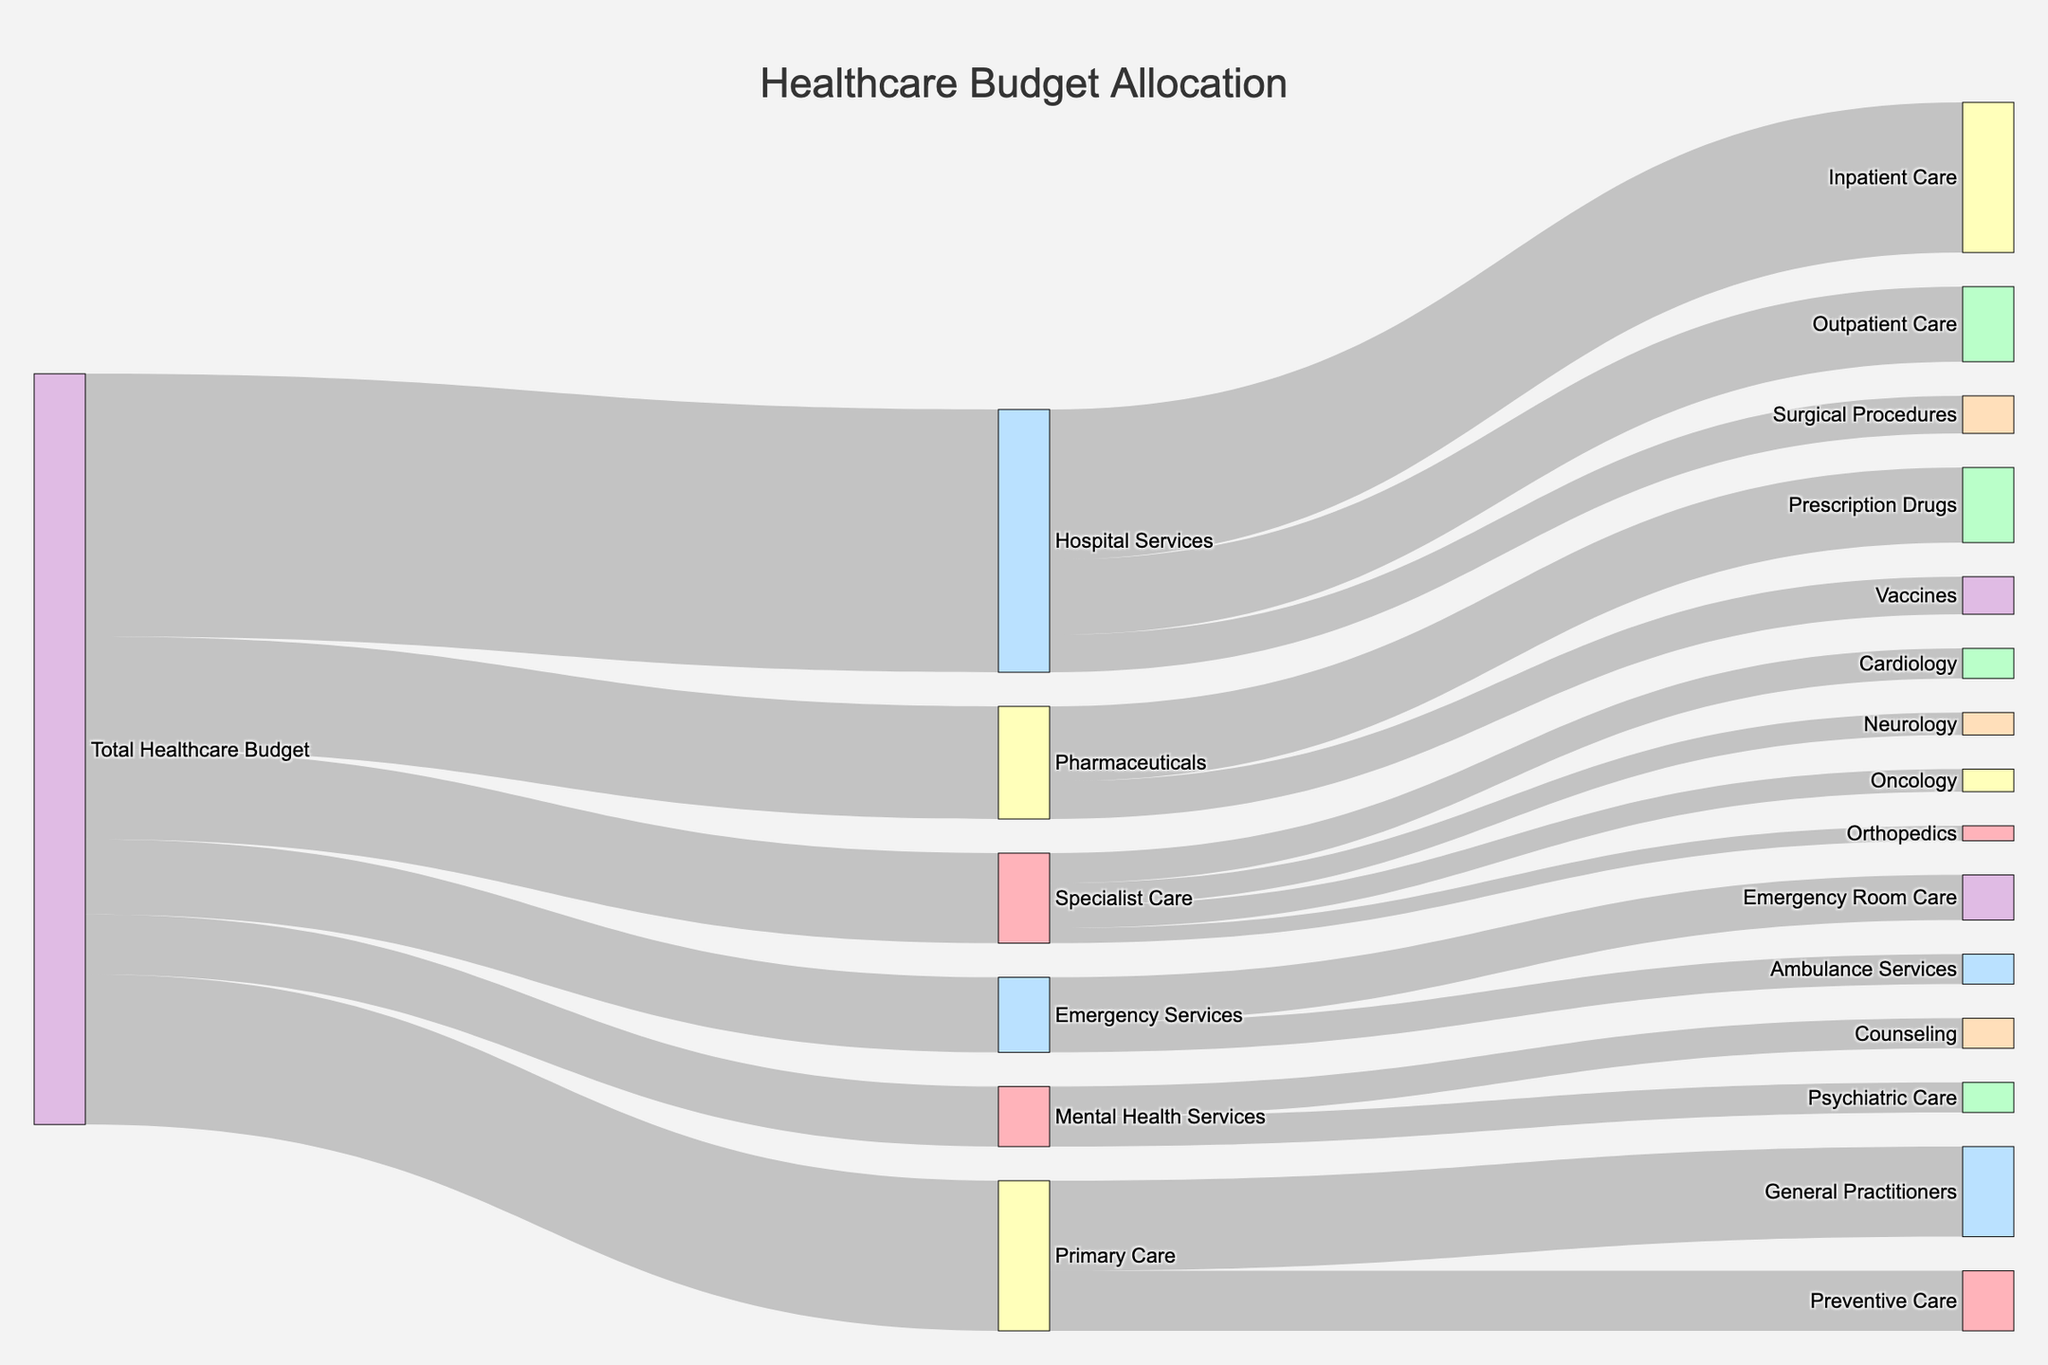What is the title of the figure? The title of the figure is located at the top and is styled in a larger font size, clearly indicating the main subject of the diagram. The title reads 'Healthcare Budget Allocation'.
Answer: Healthcare Budget Allocation What is the largest allocation of the Total Healthcare Budget? From the width of the flows in the Sankey Diagram, it visually appears that 'Hospital Services' receives the largest allocation. The value associated with 'Hospital Services' is 35.
Answer: Hospital Services How much budget is allocated to General Practitioners within Primary Care? The flow from 'Primary Care' to 'General Practitioners' in the diagram shows the specific allocation, which is labeled with the value 12.
Answer: 12 Which service under Pharmaceuticals receives more allocation, Prescription Drugs or Vaccines? The Sankey Diagram shows two separate flows under 'Pharmaceuticals': 'Prescription Drugs' receives a value of 10, and 'Vaccines' receives a value of 5. Comparing the two values directly, 'Prescription Drugs' receives more allocation.
Answer: Prescription Drugs How much combined budget is allocated to 'Cardiology', 'Oncology', 'Neurology', and 'Orthopedics' under Specialist Care? Summing up the values for 'Cardiology' (4), 'Oncology' (3), 'Neurology' (3), and 'Orthopedics' (2): 4 + 3 + 3 + 2 gives a total of 12.
Answer: 12 Is the allocation to Emergency Room Care greater than or less than Ambulance Services? The Sankey Diagram shows that 'Emergency Room Care' receives an allocation of 6, while 'Ambulance Services' receives an allocation of 4. Thus, 'Emergency Room Care' is greater than 'Ambulance Services'.
Answer: Greater than What total value is allocated to 'Inpatient Care', 'Outpatient Care', and 'Surgical Procedures' under Hospital Services? The Sankey Diagram displays the values for 'Inpatient Care' (20), 'Outpatient Care' (10), and 'Surgical Procedures' (5). Summing these allocations: 20 + 10 + 5 equals 35.
Answer: 35 What is the smallest service allocation under the Total Healthcare Budget? By visually inspecting the flows from 'Total Healthcare Budget', the smallest individual allocation is to 'Mental Health Services' with a value of 8.
Answer: Mental Health Services If we consider the combined allocation to both Counseling and Psychiatric Care, does Mental Health Services receive more or less than Emergency Services' total? Mental Health Services has 'Counseling' (4) and 'Psychiatric Care' (4), summing to 8. Emergency Services has 'Ambulance Services' (4) and 'Emergency Room Care' (6), summing to 10. Therefore, the total allocation to Mental Health Services (8) is less than Emergency Services (10).
Answer: Less than 